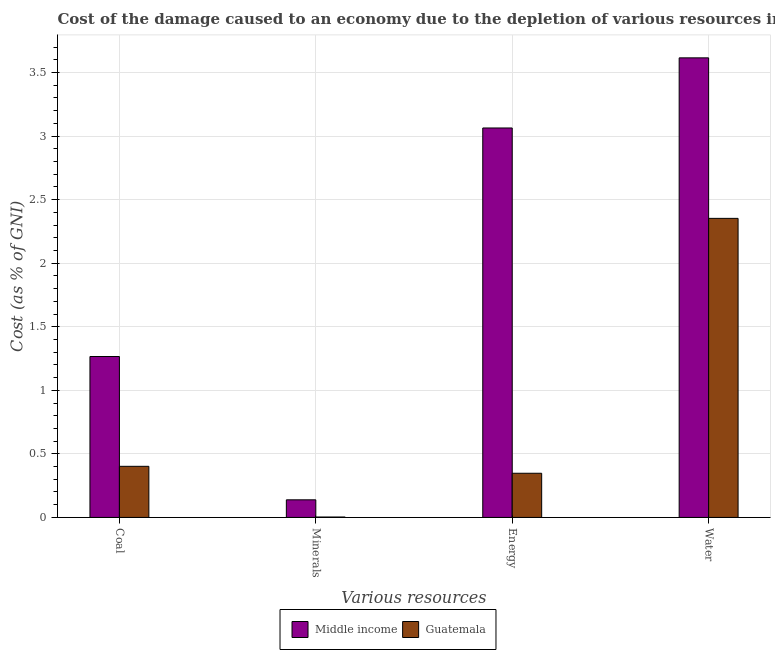How many different coloured bars are there?
Your answer should be very brief. 2. Are the number of bars per tick equal to the number of legend labels?
Offer a very short reply. Yes. How many bars are there on the 2nd tick from the right?
Your answer should be very brief. 2. What is the label of the 1st group of bars from the left?
Offer a terse response. Coal. What is the cost of damage due to depletion of minerals in Guatemala?
Keep it short and to the point. 0. Across all countries, what is the maximum cost of damage due to depletion of coal?
Your answer should be compact. 1.27. Across all countries, what is the minimum cost of damage due to depletion of minerals?
Give a very brief answer. 0. In which country was the cost of damage due to depletion of water maximum?
Provide a succinct answer. Middle income. In which country was the cost of damage due to depletion of energy minimum?
Offer a very short reply. Guatemala. What is the total cost of damage due to depletion of energy in the graph?
Provide a succinct answer. 3.41. What is the difference between the cost of damage due to depletion of coal in Guatemala and that in Middle income?
Keep it short and to the point. -0.86. What is the difference between the cost of damage due to depletion of water in Middle income and the cost of damage due to depletion of minerals in Guatemala?
Make the answer very short. 3.61. What is the average cost of damage due to depletion of energy per country?
Offer a terse response. 1.71. What is the difference between the cost of damage due to depletion of coal and cost of damage due to depletion of water in Guatemala?
Your response must be concise. -1.95. What is the ratio of the cost of damage due to depletion of energy in Middle income to that in Guatemala?
Your answer should be very brief. 8.82. Is the cost of damage due to depletion of energy in Guatemala less than that in Middle income?
Ensure brevity in your answer.  Yes. What is the difference between the highest and the second highest cost of damage due to depletion of energy?
Give a very brief answer. 2.72. What is the difference between the highest and the lowest cost of damage due to depletion of minerals?
Offer a very short reply. 0.14. Is it the case that in every country, the sum of the cost of damage due to depletion of water and cost of damage due to depletion of minerals is greater than the sum of cost of damage due to depletion of energy and cost of damage due to depletion of coal?
Provide a succinct answer. No. Is it the case that in every country, the sum of the cost of damage due to depletion of coal and cost of damage due to depletion of minerals is greater than the cost of damage due to depletion of energy?
Your answer should be very brief. No. Are all the bars in the graph horizontal?
Make the answer very short. No. How many countries are there in the graph?
Offer a very short reply. 2. Are the values on the major ticks of Y-axis written in scientific E-notation?
Offer a terse response. No. Does the graph contain any zero values?
Your response must be concise. No. Where does the legend appear in the graph?
Offer a very short reply. Bottom center. How many legend labels are there?
Provide a succinct answer. 2. What is the title of the graph?
Offer a very short reply. Cost of the damage caused to an economy due to the depletion of various resources in 2001 . Does "Ukraine" appear as one of the legend labels in the graph?
Your response must be concise. No. What is the label or title of the X-axis?
Give a very brief answer. Various resources. What is the label or title of the Y-axis?
Your response must be concise. Cost (as % of GNI). What is the Cost (as % of GNI) of Middle income in Coal?
Keep it short and to the point. 1.27. What is the Cost (as % of GNI) in Guatemala in Coal?
Provide a short and direct response. 0.4. What is the Cost (as % of GNI) of Middle income in Minerals?
Your response must be concise. 0.14. What is the Cost (as % of GNI) of Guatemala in Minerals?
Your answer should be compact. 0. What is the Cost (as % of GNI) in Middle income in Energy?
Give a very brief answer. 3.06. What is the Cost (as % of GNI) in Guatemala in Energy?
Give a very brief answer. 0.35. What is the Cost (as % of GNI) of Middle income in Water?
Keep it short and to the point. 3.61. What is the Cost (as % of GNI) in Guatemala in Water?
Keep it short and to the point. 2.35. Across all Various resources, what is the maximum Cost (as % of GNI) of Middle income?
Offer a terse response. 3.61. Across all Various resources, what is the maximum Cost (as % of GNI) of Guatemala?
Your response must be concise. 2.35. Across all Various resources, what is the minimum Cost (as % of GNI) of Middle income?
Give a very brief answer. 0.14. Across all Various resources, what is the minimum Cost (as % of GNI) in Guatemala?
Provide a succinct answer. 0. What is the total Cost (as % of GNI) in Middle income in the graph?
Provide a short and direct response. 8.08. What is the total Cost (as % of GNI) in Guatemala in the graph?
Give a very brief answer. 3.1. What is the difference between the Cost (as % of GNI) of Middle income in Coal and that in Minerals?
Give a very brief answer. 1.13. What is the difference between the Cost (as % of GNI) in Guatemala in Coal and that in Minerals?
Give a very brief answer. 0.4. What is the difference between the Cost (as % of GNI) in Middle income in Coal and that in Energy?
Your response must be concise. -1.8. What is the difference between the Cost (as % of GNI) of Guatemala in Coal and that in Energy?
Your answer should be compact. 0.05. What is the difference between the Cost (as % of GNI) of Middle income in Coal and that in Water?
Offer a terse response. -2.35. What is the difference between the Cost (as % of GNI) in Guatemala in Coal and that in Water?
Your response must be concise. -1.95. What is the difference between the Cost (as % of GNI) in Middle income in Minerals and that in Energy?
Your answer should be compact. -2.92. What is the difference between the Cost (as % of GNI) of Guatemala in Minerals and that in Energy?
Ensure brevity in your answer.  -0.34. What is the difference between the Cost (as % of GNI) in Middle income in Minerals and that in Water?
Offer a terse response. -3.48. What is the difference between the Cost (as % of GNI) of Guatemala in Minerals and that in Water?
Offer a terse response. -2.35. What is the difference between the Cost (as % of GNI) of Middle income in Energy and that in Water?
Provide a succinct answer. -0.55. What is the difference between the Cost (as % of GNI) of Guatemala in Energy and that in Water?
Ensure brevity in your answer.  -2. What is the difference between the Cost (as % of GNI) of Middle income in Coal and the Cost (as % of GNI) of Guatemala in Minerals?
Ensure brevity in your answer.  1.26. What is the difference between the Cost (as % of GNI) of Middle income in Coal and the Cost (as % of GNI) of Guatemala in Energy?
Provide a short and direct response. 0.92. What is the difference between the Cost (as % of GNI) of Middle income in Coal and the Cost (as % of GNI) of Guatemala in Water?
Your answer should be very brief. -1.09. What is the difference between the Cost (as % of GNI) in Middle income in Minerals and the Cost (as % of GNI) in Guatemala in Energy?
Keep it short and to the point. -0.21. What is the difference between the Cost (as % of GNI) in Middle income in Minerals and the Cost (as % of GNI) in Guatemala in Water?
Ensure brevity in your answer.  -2.21. What is the difference between the Cost (as % of GNI) in Middle income in Energy and the Cost (as % of GNI) in Guatemala in Water?
Offer a very short reply. 0.71. What is the average Cost (as % of GNI) in Middle income per Various resources?
Make the answer very short. 2.02. What is the average Cost (as % of GNI) in Guatemala per Various resources?
Keep it short and to the point. 0.78. What is the difference between the Cost (as % of GNI) of Middle income and Cost (as % of GNI) of Guatemala in Coal?
Keep it short and to the point. 0.86. What is the difference between the Cost (as % of GNI) of Middle income and Cost (as % of GNI) of Guatemala in Minerals?
Your answer should be compact. 0.14. What is the difference between the Cost (as % of GNI) in Middle income and Cost (as % of GNI) in Guatemala in Energy?
Provide a succinct answer. 2.72. What is the difference between the Cost (as % of GNI) of Middle income and Cost (as % of GNI) of Guatemala in Water?
Your answer should be compact. 1.26. What is the ratio of the Cost (as % of GNI) of Middle income in Coal to that in Minerals?
Keep it short and to the point. 9.14. What is the ratio of the Cost (as % of GNI) of Guatemala in Coal to that in Minerals?
Give a very brief answer. 125.9. What is the ratio of the Cost (as % of GNI) of Middle income in Coal to that in Energy?
Keep it short and to the point. 0.41. What is the ratio of the Cost (as % of GNI) of Guatemala in Coal to that in Energy?
Give a very brief answer. 1.16. What is the ratio of the Cost (as % of GNI) of Middle income in Coal to that in Water?
Your answer should be very brief. 0.35. What is the ratio of the Cost (as % of GNI) in Guatemala in Coal to that in Water?
Offer a terse response. 0.17. What is the ratio of the Cost (as % of GNI) in Middle income in Minerals to that in Energy?
Your answer should be compact. 0.05. What is the ratio of the Cost (as % of GNI) in Guatemala in Minerals to that in Energy?
Keep it short and to the point. 0.01. What is the ratio of the Cost (as % of GNI) in Middle income in Minerals to that in Water?
Give a very brief answer. 0.04. What is the ratio of the Cost (as % of GNI) in Guatemala in Minerals to that in Water?
Your response must be concise. 0. What is the ratio of the Cost (as % of GNI) of Middle income in Energy to that in Water?
Your answer should be very brief. 0.85. What is the ratio of the Cost (as % of GNI) of Guatemala in Energy to that in Water?
Keep it short and to the point. 0.15. What is the difference between the highest and the second highest Cost (as % of GNI) of Middle income?
Give a very brief answer. 0.55. What is the difference between the highest and the second highest Cost (as % of GNI) of Guatemala?
Keep it short and to the point. 1.95. What is the difference between the highest and the lowest Cost (as % of GNI) of Middle income?
Provide a succinct answer. 3.48. What is the difference between the highest and the lowest Cost (as % of GNI) in Guatemala?
Ensure brevity in your answer.  2.35. 